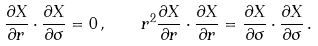Convert formula to latex. <formula><loc_0><loc_0><loc_500><loc_500>\frac { \partial X } { \partial r } \cdot \frac { \partial X } { \partial \sigma } = 0 \, , \quad r ^ { 2 } \frac { \partial X } { \partial r } \cdot \frac { \partial X } { \partial r } = \frac { \partial X } { \partial \sigma } \cdot \frac { \partial X } { \partial \sigma } \, .</formula> 